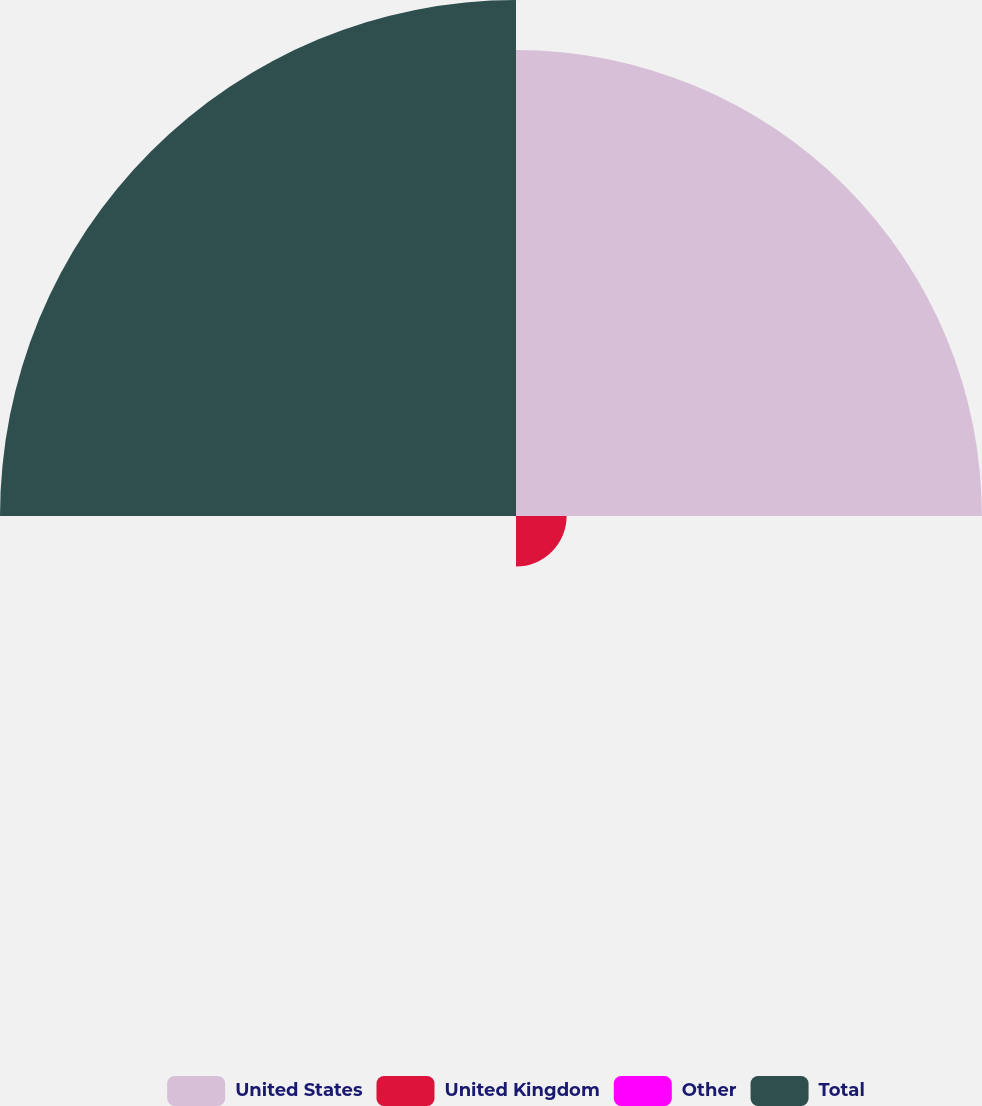Convert chart to OTSL. <chart><loc_0><loc_0><loc_500><loc_500><pie_chart><fcel>United States<fcel>United Kingdom<fcel>Other<fcel>Total<nl><fcel>45.1%<fcel>4.9%<fcel>0.05%<fcel>49.95%<nl></chart> 